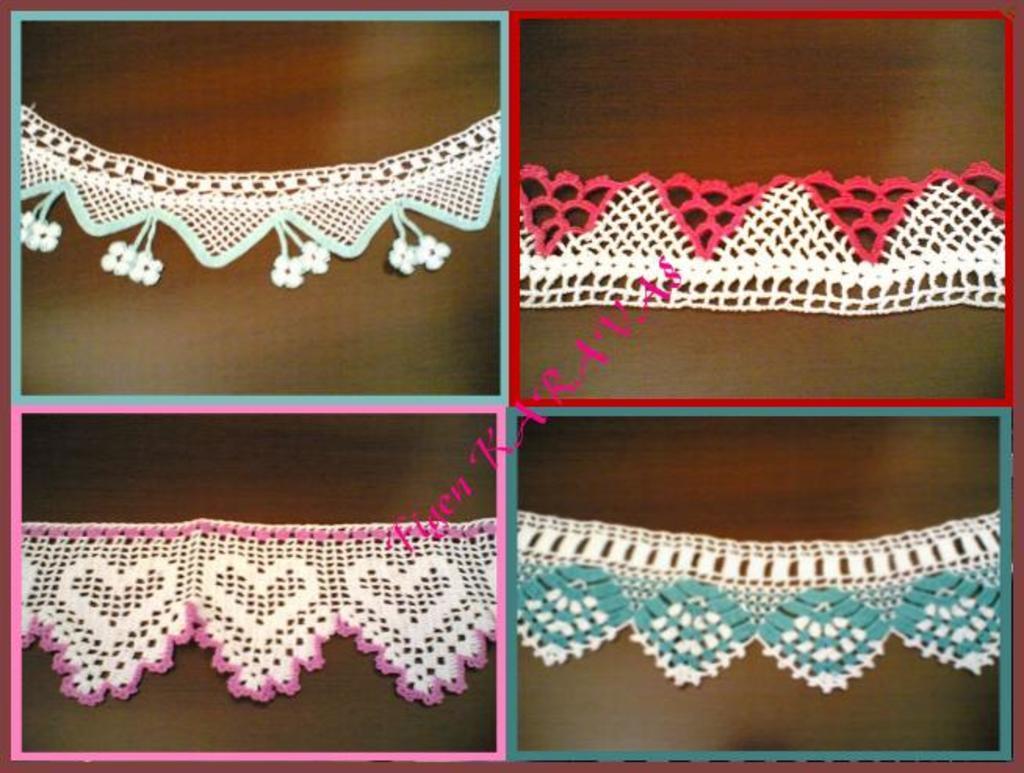Can you describe this image briefly? In this picture we can see crochets and some text. 